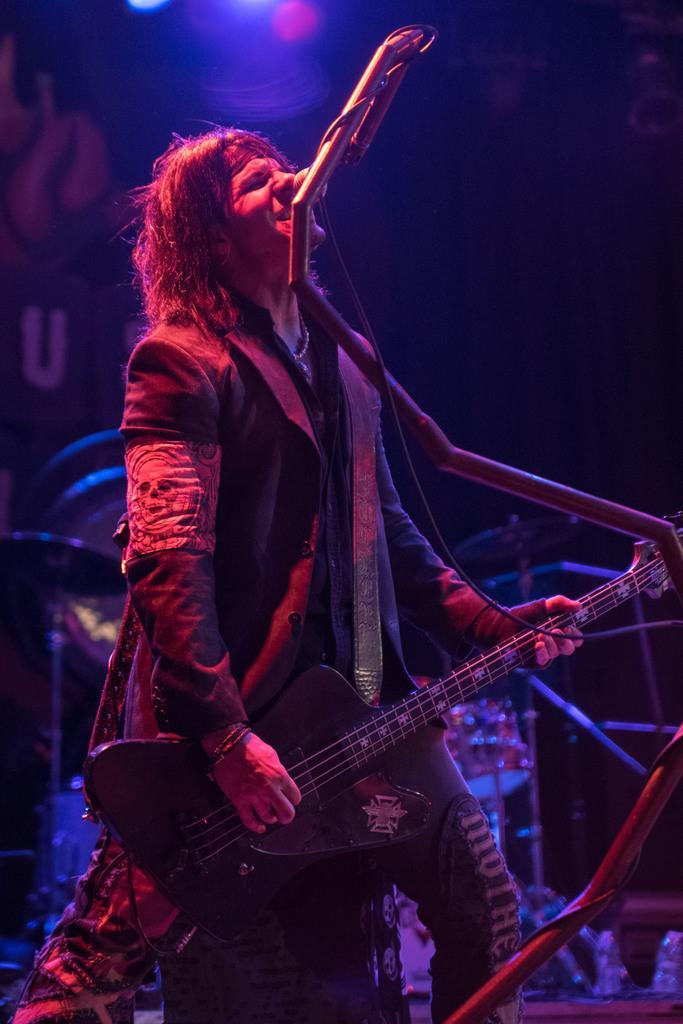In one or two sentences, can you explain what this image depicts? In this image person is singing by holding the guitar and in front of him there is a mike. At the back side there are other musical instruments. 